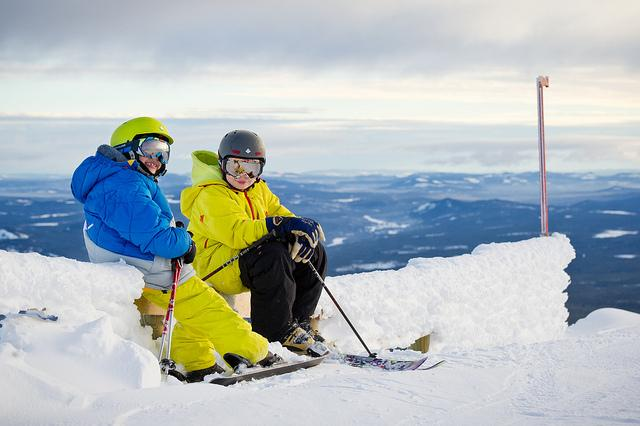What are they doing?

Choices:
A) waiting
B) eating
C) arguing
D) resting resting 